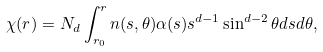<formula> <loc_0><loc_0><loc_500><loc_500>\chi ( r ) = N _ { d } \int _ { r _ { 0 } } ^ { r } n ( s , \theta ) \alpha ( s ) s ^ { d - 1 } \sin ^ { d - 2 } \theta d s d \theta ,</formula> 